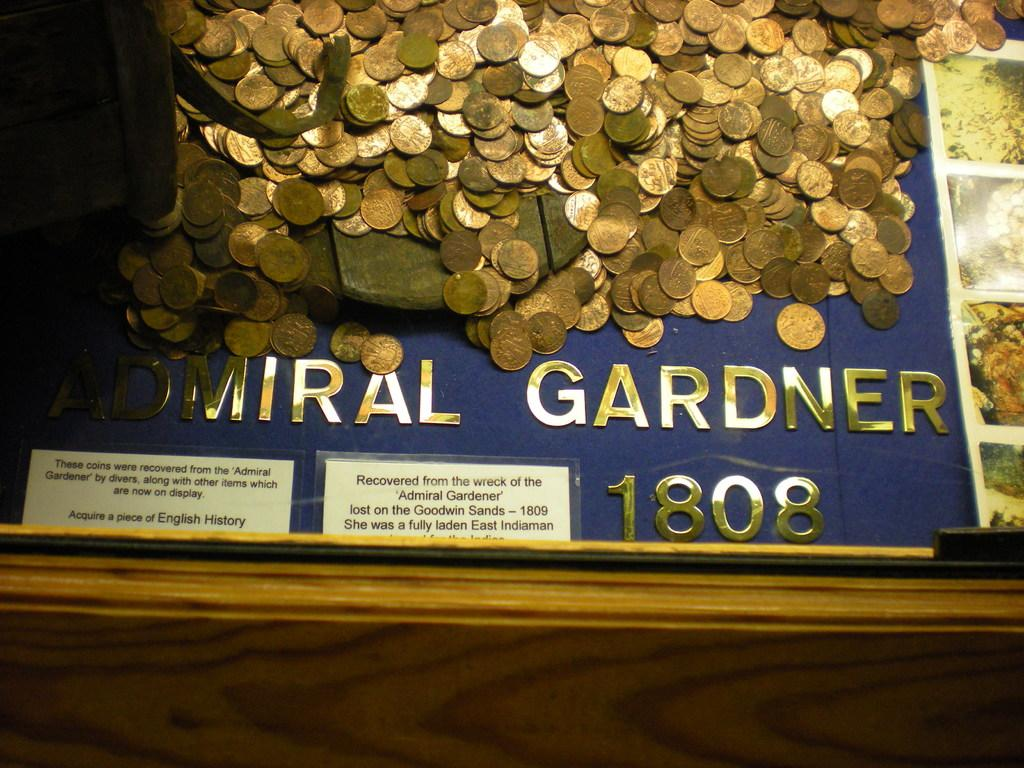<image>
Give a short and clear explanation of the subsequent image. A lots of gold coins with 1808 at the bottom of the display. 